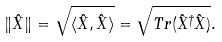<formula> <loc_0><loc_0><loc_500><loc_500>\| \hat { X } \| = \sqrt { \langle \hat { X } , \hat { X } \rangle } = \sqrt { T r ( \hat { X } ^ { \dag } \hat { X } ) } .</formula> 